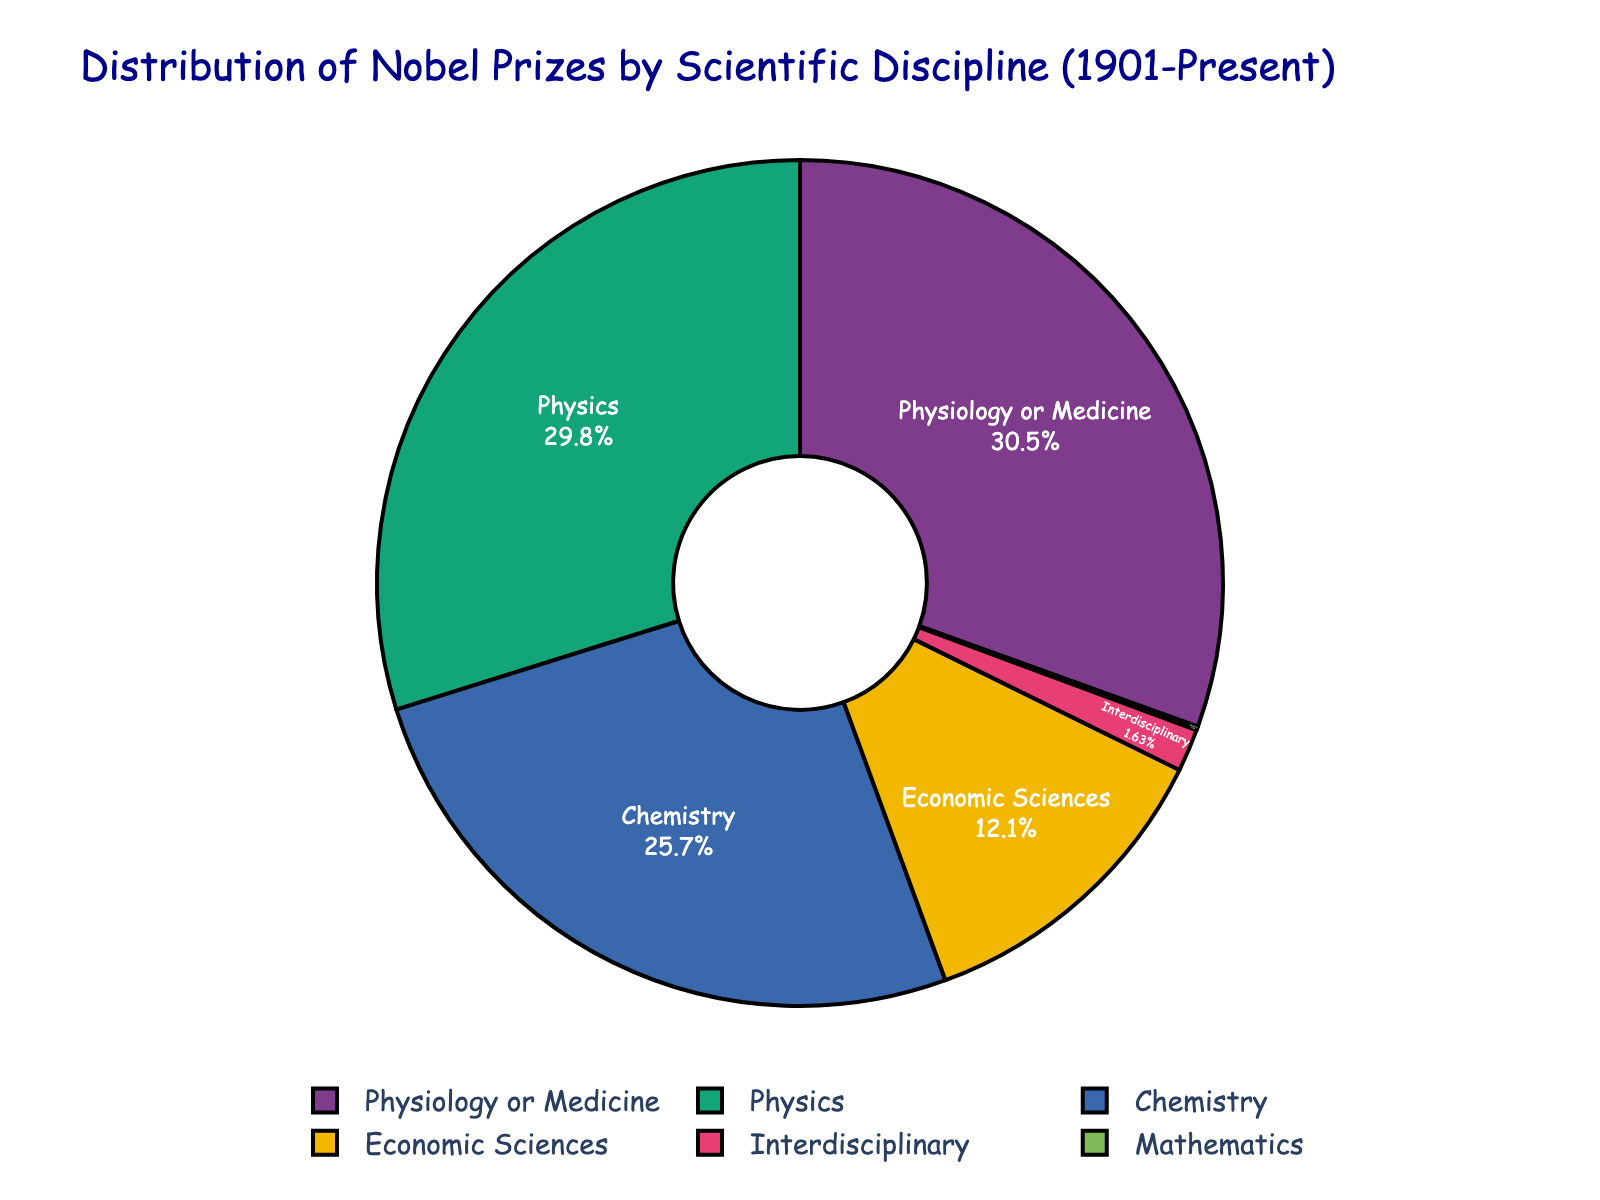What's the largest segment in the pie chart? The largest segment in the pie chart is the one with the highest number of prizes. By looking at the chart, we see that the segment for "Physiology or Medicine" has the highest count with 224 prizes.
Answer: Physiology or Medicine Which category has received exactly one prize? By examining the segments and their labels, it's evident that "Mathematics" has received exactly one prize.
Answer: Mathematics How many more prizes has Physics received compared to Chemistry? The chart shows Physics has 219 prizes while Chemistry has 189. Subtracting Chemistry's total from Physics's total gives 219 - 189 = 30.
Answer: 30 Which category is represented by the smallest segment that is not zero? Looking through the segments, the smallest non-zero segment belongs to the "Interdisciplinary" category with 12 prizes.
Answer: Interdisciplinary What's the sum of prizes awarded in the categories other than Economic Sciences and Interdisciplinary? To find this, sum the prizes in Physics, Chemistry, Physiology or Medicine, and Mathematics: 219 + 189 + 224 + 1 = 633.
Answer: 633 Which category has fewer prizes: Physics or Economic Sciences? By comparing the numbers, Physics has 219 prizes and Economic Sciences has 89 prizes. Economic Sciences has fewer prizes.
Answer: Economic Sciences If you combine the prizes of Chemistry and Physiology or Medicine, how does this total compare to Physics? Combined, Chemistry (189) and Physiology or Medicine (224) give a total of 413. Compared to Physics (219), 413 is greater than 219.
Answer: Greater What is the percentage of prizes awarded in Interdisciplinary studies? By referring to the pie chart, the segment for "Interdisciplinary" should display its percentage of the total. By adding all numbers (219+189+224+89+12+1=734), and calculating 12/734*100, it is about 1.63%.
Answer: 1.63% What's the numerical difference between the largest and smallest segments? The largest segment is Physiology or Medicine with 224 prizes, and the smallest is Mathematics with 1 prize. The difference is 224 - 1 = 223.
Answer: 223 